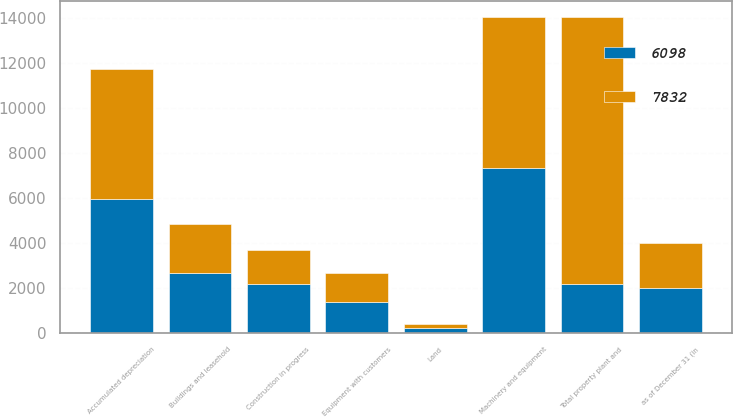Convert chart. <chart><loc_0><loc_0><loc_500><loc_500><stacked_bar_chart><ecel><fcel>as of December 31 (in<fcel>Land<fcel>Buildings and leasehold<fcel>Machinery and equipment<fcel>Equipment with customers<fcel>Construction in progress<fcel>Total property plant and<fcel>Accumulated depreciation<nl><fcel>6098<fcel>2013<fcel>220<fcel>2670<fcel>7360<fcel>1361<fcel>2184<fcel>2181<fcel>5963<nl><fcel>7832<fcel>2012<fcel>190<fcel>2181<fcel>6691<fcel>1295<fcel>1512<fcel>11869<fcel>5771<nl></chart> 